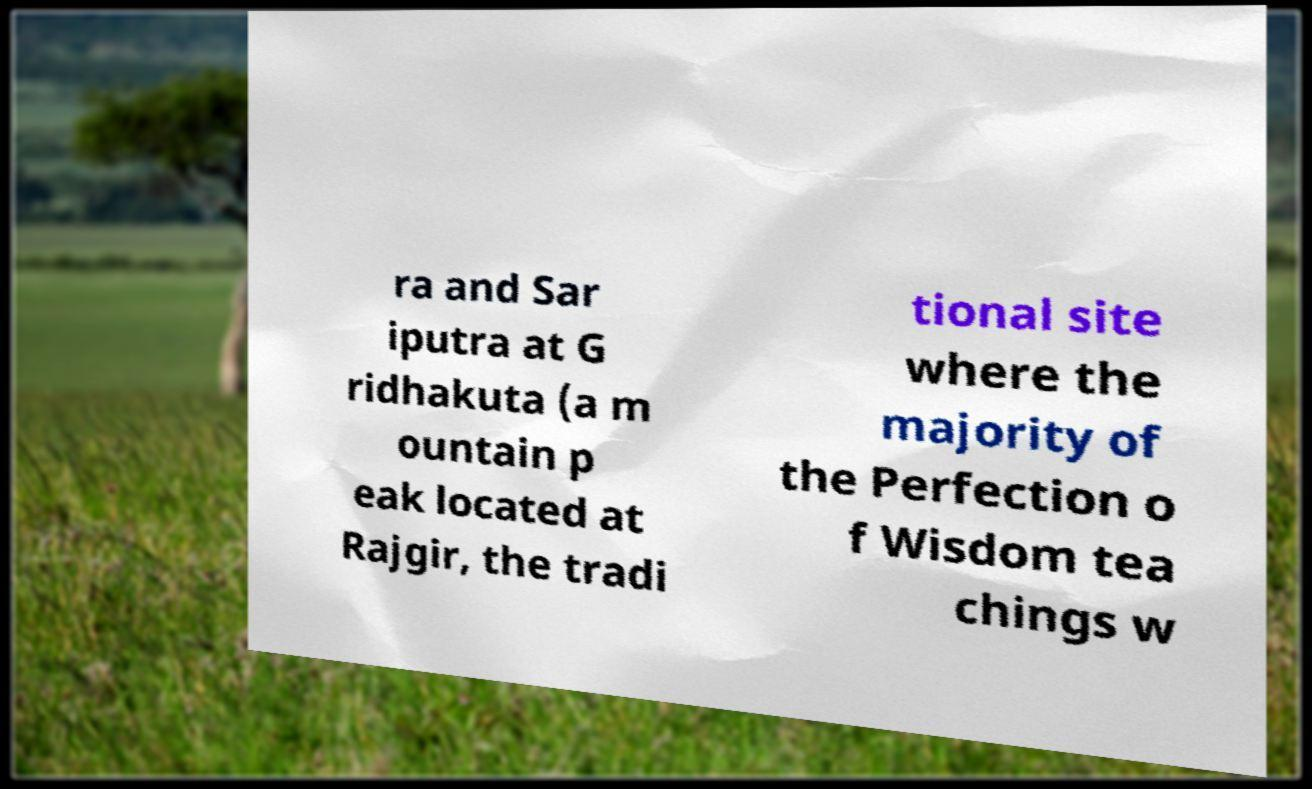Could you extract and type out the text from this image? ra and Sar iputra at G ridhakuta (a m ountain p eak located at Rajgir, the tradi tional site where the majority of the Perfection o f Wisdom tea chings w 